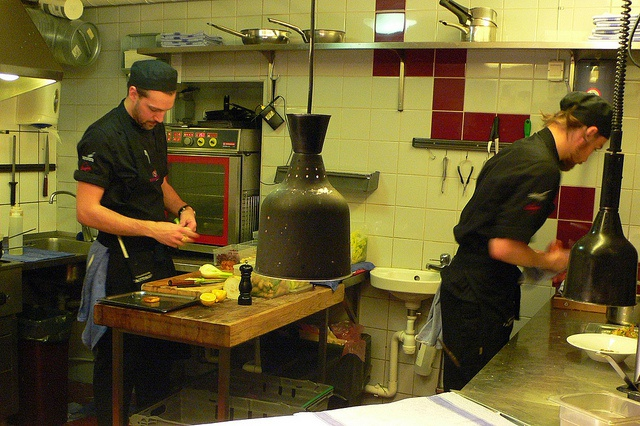Describe the objects in this image and their specific colors. I can see people in olive, black, maroon, and brown tones, people in olive, black, brown, and maroon tones, dining table in olive, maroon, and black tones, oven in olive, black, and maroon tones, and sink in olive, khaki, and tan tones in this image. 